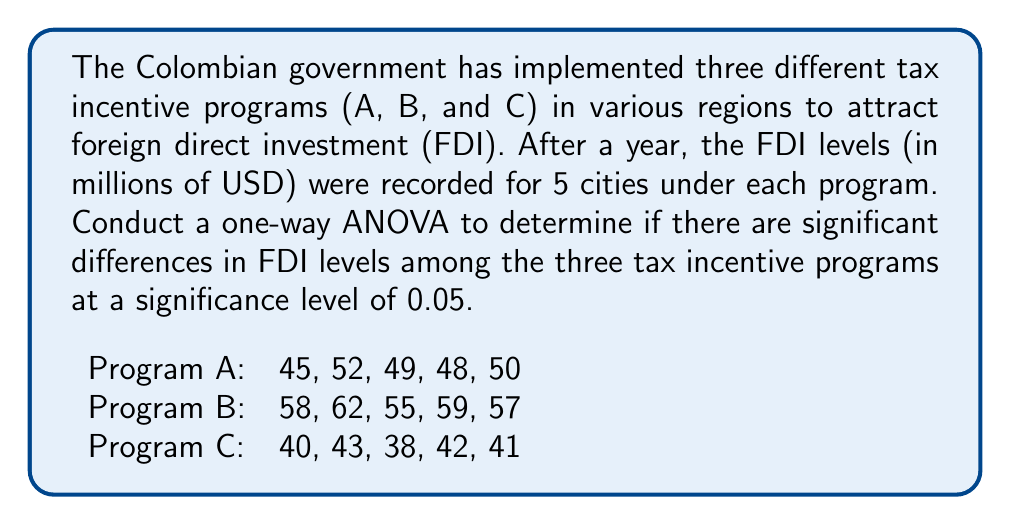Provide a solution to this math problem. To conduct a one-way ANOVA, we need to follow these steps:

1. Calculate the sum of squares between groups (SSB), within groups (SSW), and total (SST).
2. Calculate the degrees of freedom for between groups (dfB), within groups (dfW), and total (dfT).
3. Calculate the mean squares for between groups (MSB) and within groups (MSW).
4. Calculate the F-statistic.
5. Compare the F-statistic to the critical F-value.

Step 1: Calculate sum of squares

First, we need to calculate the grand mean:
$$ \bar{X} = \frac{45 + 52 + ... + 41}{15} = 49.27 $$

Now, we can calculate SSB, SSW, and SST:

SSB:
$$ SSB = 5[(49.8 - 49.27)^2 + (58.2 - 49.27)^2 + (40.8 - 49.27)^2] = 1014.13 $$

SSW:
$$ SSW = [(45-49.8)^2 + (52-49.8)^2 + ... + (41-40.8)^2] = 140.8 $$

SST:
$$ SST = SSB + SSW = 1014.13 + 140.8 = 1154.93 $$

Step 2: Calculate degrees of freedom

$$ df_B = k - 1 = 3 - 1 = 2 $$
$$ df_W = N - k = 15 - 3 = 12 $$
$$ df_T = N - 1 = 15 - 1 = 14 $$

Where k is the number of groups and N is the total number of observations.

Step 3: Calculate mean squares

$$ MSB = \frac{SSB}{df_B} = \frac{1014.13}{2} = 507.065 $$
$$ MSW = \frac{SSW}{df_W} = \frac{140.8}{12} = 11.73 $$

Step 4: Calculate F-statistic

$$ F = \frac{MSB}{MSW} = \frac{507.065}{11.73} = 43.23 $$

Step 5: Compare F-statistic to critical F-value

The critical F-value for df_B = 2, df_W = 12, and α = 0.05 is approximately 3.89.

Since our calculated F-statistic (43.23) is greater than the critical F-value (3.89), we reject the null hypothesis.
Answer: The one-way ANOVA results (F(2, 12) = 43.23, p < 0.05) indicate that there are significant differences in FDI levels among the three tax incentive programs at the 0.05 significance level. 